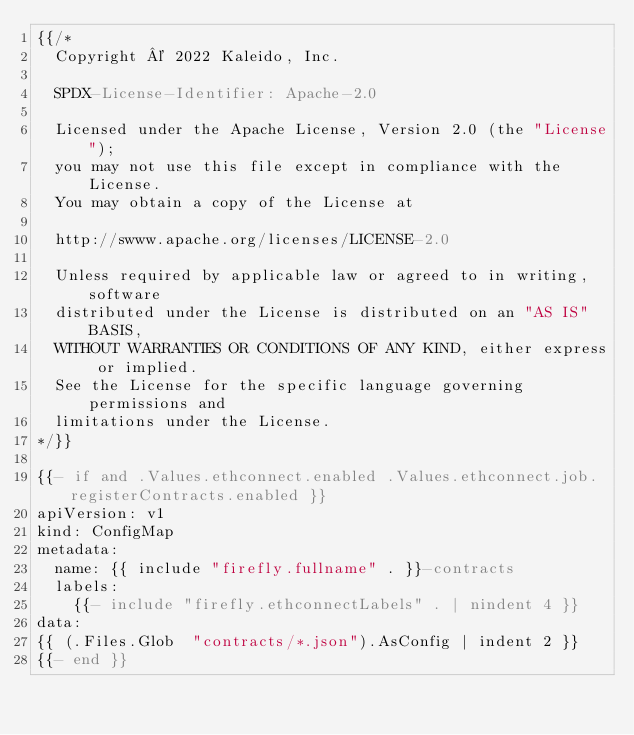<code> <loc_0><loc_0><loc_500><loc_500><_YAML_>{{/*
  Copyright © 2022 Kaleido, Inc.

  SPDX-License-Identifier: Apache-2.0

  Licensed under the Apache License, Version 2.0 (the "License");
  you may not use this file except in compliance with the License.
  You may obtain a copy of the License at

  http://swww.apache.org/licenses/LICENSE-2.0

  Unless required by applicable law or agreed to in writing, software
  distributed under the License is distributed on an "AS IS" BASIS,
  WITHOUT WARRANTIES OR CONDITIONS OF ANY KIND, either express or implied.
  See the License for the specific language governing permissions and
  limitations under the License.
*/}}

{{- if and .Values.ethconnect.enabled .Values.ethconnect.job.registerContracts.enabled }}
apiVersion: v1
kind: ConfigMap
metadata:
  name: {{ include "firefly.fullname" . }}-contracts
  labels:
    {{- include "firefly.ethconnectLabels" . | nindent 4 }}
data:
{{ (.Files.Glob  "contracts/*.json").AsConfig | indent 2 }}
{{- end }}
</code> 